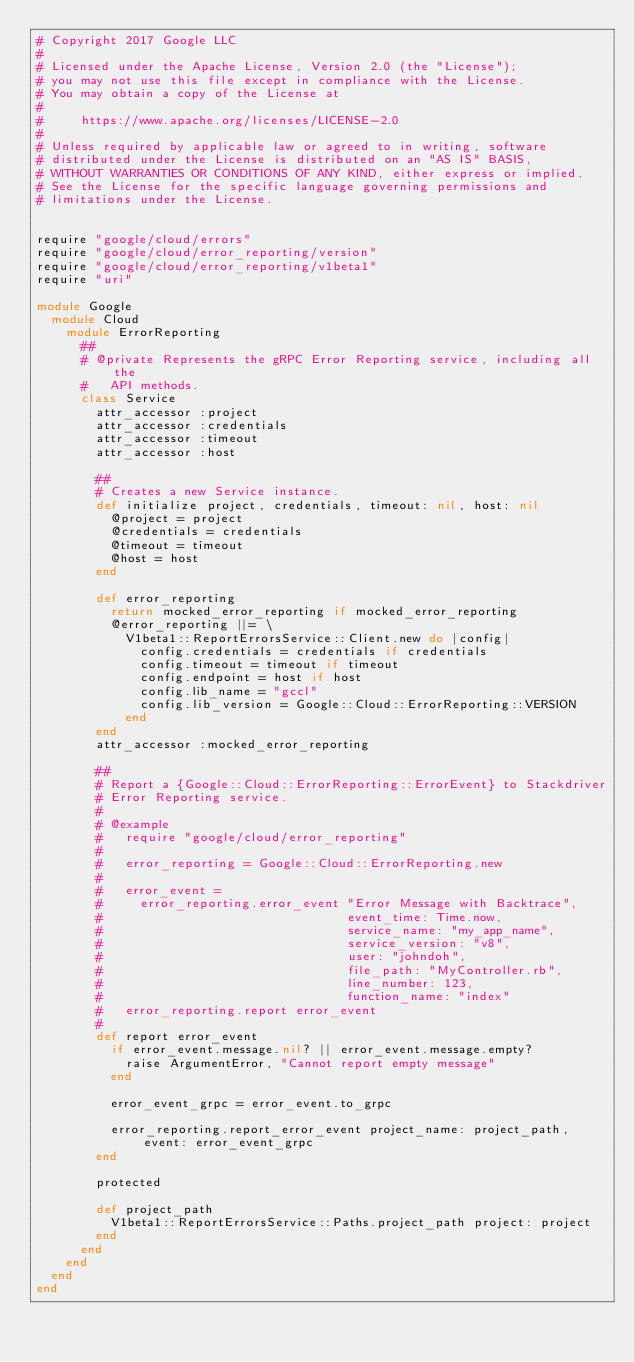<code> <loc_0><loc_0><loc_500><loc_500><_Ruby_># Copyright 2017 Google LLC
#
# Licensed under the Apache License, Version 2.0 (the "License");
# you may not use this file except in compliance with the License.
# You may obtain a copy of the License at
#
#     https://www.apache.org/licenses/LICENSE-2.0
#
# Unless required by applicable law or agreed to in writing, software
# distributed under the License is distributed on an "AS IS" BASIS,
# WITHOUT WARRANTIES OR CONDITIONS OF ANY KIND, either express or implied.
# See the License for the specific language governing permissions and
# limitations under the License.


require "google/cloud/errors"
require "google/cloud/error_reporting/version"
require "google/cloud/error_reporting/v1beta1"
require "uri"

module Google
  module Cloud
    module ErrorReporting
      ##
      # @private Represents the gRPC Error Reporting service, including all the
      #   API methods.
      class Service
        attr_accessor :project
        attr_accessor :credentials
        attr_accessor :timeout
        attr_accessor :host

        ##
        # Creates a new Service instance.
        def initialize project, credentials, timeout: nil, host: nil
          @project = project
          @credentials = credentials
          @timeout = timeout
          @host = host
        end

        def error_reporting
          return mocked_error_reporting if mocked_error_reporting
          @error_reporting ||= \
            V1beta1::ReportErrorsService::Client.new do |config|
              config.credentials = credentials if credentials
              config.timeout = timeout if timeout
              config.endpoint = host if host
              config.lib_name = "gccl"
              config.lib_version = Google::Cloud::ErrorReporting::VERSION
            end
        end
        attr_accessor :mocked_error_reporting

        ##
        # Report a {Google::Cloud::ErrorReporting::ErrorEvent} to Stackdriver
        # Error Reporting service.
        #
        # @example
        #   require "google/cloud/error_reporting"
        #
        #   error_reporting = Google::Cloud::ErrorReporting.new
        #
        #   error_event =
        #     error_reporting.error_event "Error Message with Backtrace",
        #                                 event_time: Time.now,
        #                                 service_name: "my_app_name",
        #                                 service_version: "v8",
        #                                 user: "johndoh",
        #                                 file_path: "MyController.rb",
        #                                 line_number: 123,
        #                                 function_name: "index"
        #   error_reporting.report error_event
        #
        def report error_event
          if error_event.message.nil? || error_event.message.empty?
            raise ArgumentError, "Cannot report empty message"
          end

          error_event_grpc = error_event.to_grpc

          error_reporting.report_error_event project_name: project_path, event: error_event_grpc
        end

        protected

        def project_path
          V1beta1::ReportErrorsService::Paths.project_path project: project
        end
      end
    end
  end
end
</code> 